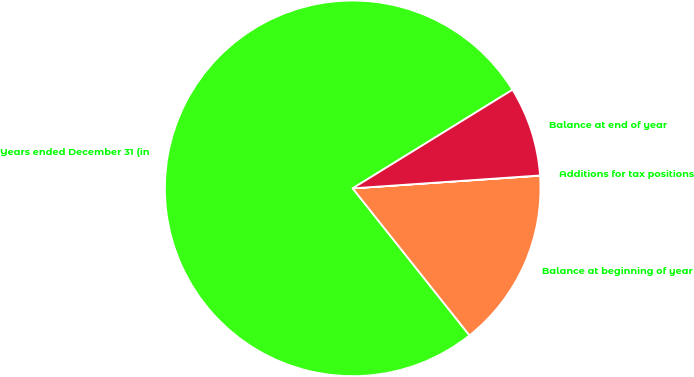<chart> <loc_0><loc_0><loc_500><loc_500><pie_chart><fcel>Years ended December 31 (in<fcel>Balance at beginning of year<fcel>Additions for tax positions<fcel>Balance at end of year<nl><fcel>76.89%<fcel>15.39%<fcel>0.02%<fcel>7.7%<nl></chart> 